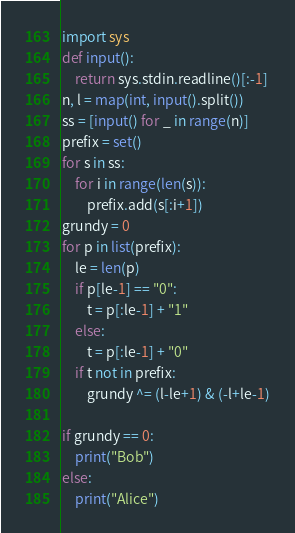<code> <loc_0><loc_0><loc_500><loc_500><_Python_>import sys
def input():
	return sys.stdin.readline()[:-1]
n, l = map(int, input().split())
ss = [input() for _ in range(n)]
prefix = set()
for s in ss:
	for i in range(len(s)):
		prefix.add(s[:i+1])
grundy = 0
for p in list(prefix):
	le = len(p)
	if p[le-1] == "0":
		t = p[:le-1] + "1"
	else:
		t = p[:le-1] + "0"
	if t not in prefix:
		grundy ^= (l-le+1) & (-l+le-1)

if grundy == 0:
	print("Bob")
else:
	print("Alice")</code> 